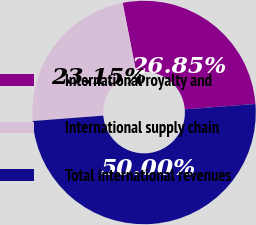Convert chart. <chart><loc_0><loc_0><loc_500><loc_500><pie_chart><fcel>International royalty and<fcel>International supply chain<fcel>Total international revenues<nl><fcel>26.85%<fcel>23.15%<fcel>50.0%<nl></chart> 